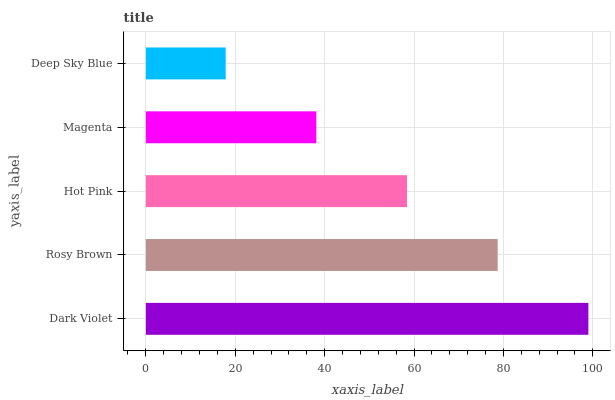Is Deep Sky Blue the minimum?
Answer yes or no. Yes. Is Dark Violet the maximum?
Answer yes or no. Yes. Is Rosy Brown the minimum?
Answer yes or no. No. Is Rosy Brown the maximum?
Answer yes or no. No. Is Dark Violet greater than Rosy Brown?
Answer yes or no. Yes. Is Rosy Brown less than Dark Violet?
Answer yes or no. Yes. Is Rosy Brown greater than Dark Violet?
Answer yes or no. No. Is Dark Violet less than Rosy Brown?
Answer yes or no. No. Is Hot Pink the high median?
Answer yes or no. Yes. Is Hot Pink the low median?
Answer yes or no. Yes. Is Deep Sky Blue the high median?
Answer yes or no. No. Is Deep Sky Blue the low median?
Answer yes or no. No. 